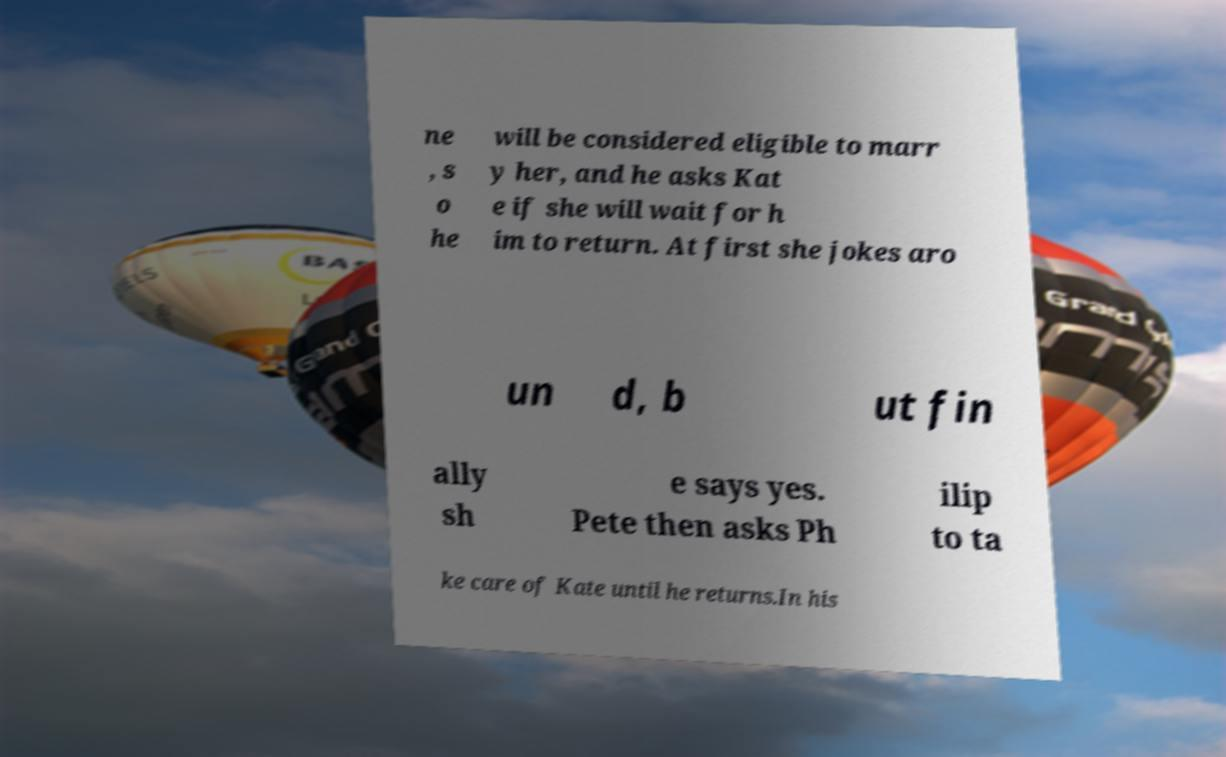Can you accurately transcribe the text from the provided image for me? ne , s o he will be considered eligible to marr y her, and he asks Kat e if she will wait for h im to return. At first she jokes aro un d, b ut fin ally sh e says yes. Pete then asks Ph ilip to ta ke care of Kate until he returns.In his 